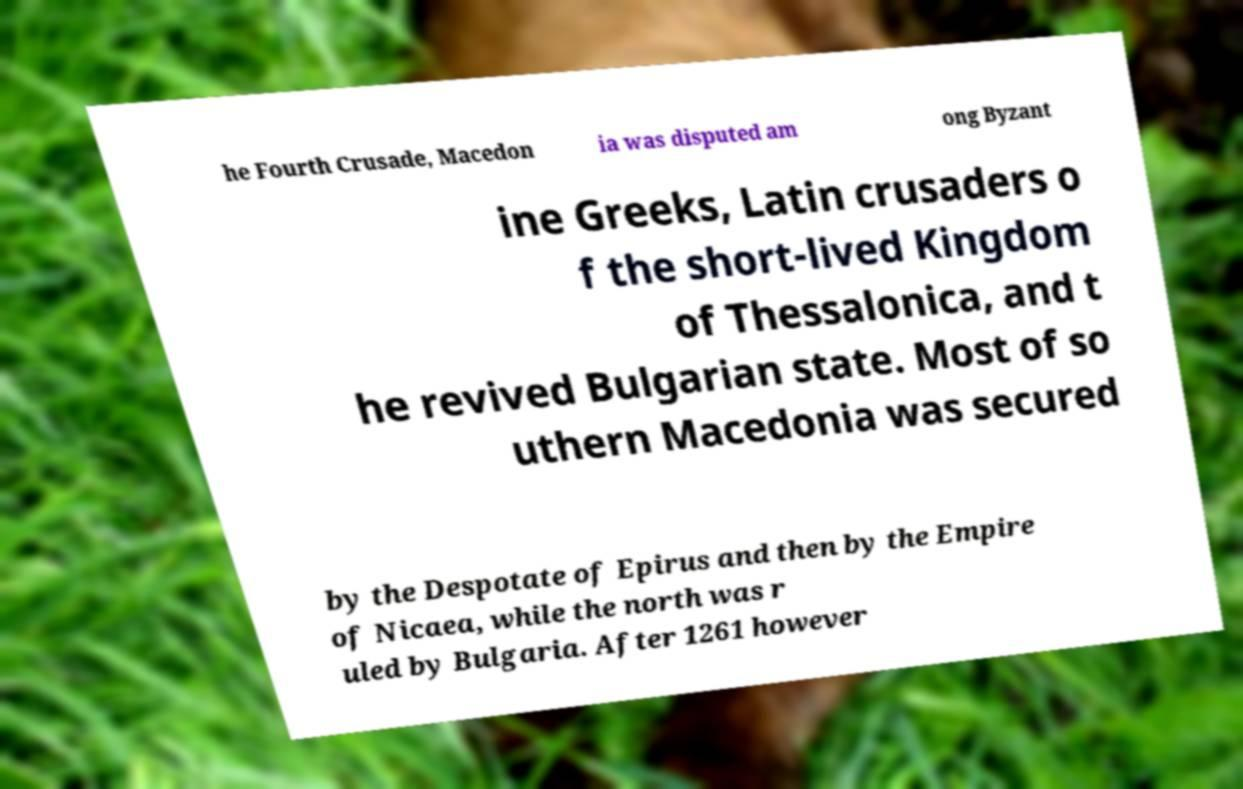I need the written content from this picture converted into text. Can you do that? he Fourth Crusade, Macedon ia was disputed am ong Byzant ine Greeks, Latin crusaders o f the short-lived Kingdom of Thessalonica, and t he revived Bulgarian state. Most of so uthern Macedonia was secured by the Despotate of Epirus and then by the Empire of Nicaea, while the north was r uled by Bulgaria. After 1261 however 